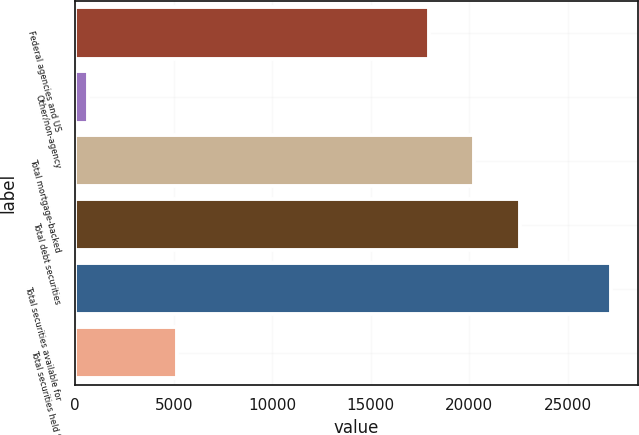<chart> <loc_0><loc_0><loc_500><loc_500><bar_chart><fcel>Federal agencies and US<fcel>Other/non-agency<fcel>Total mortgage-backed<fcel>Total debt securities<fcel>Total securities available for<fcel>Total securities held to<nl><fcel>17934<fcel>672<fcel>20251.7<fcel>22569.4<fcel>27204.8<fcel>5193<nl></chart> 